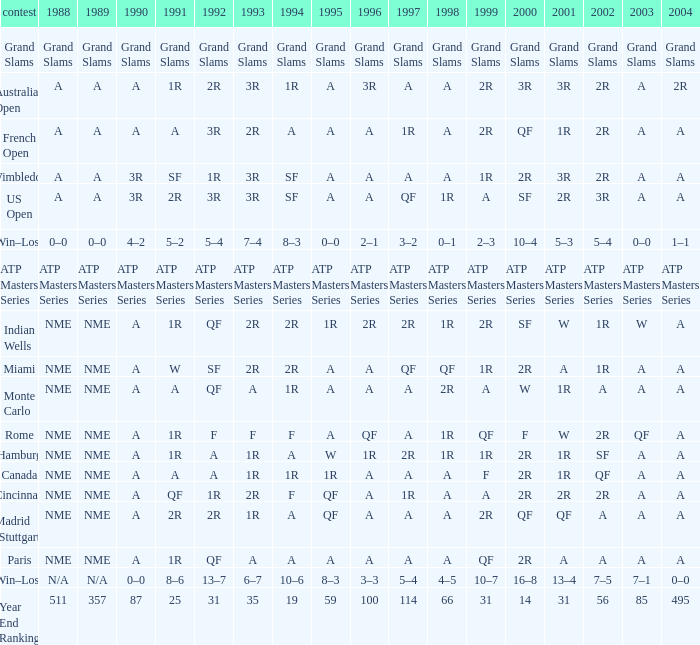What shows for 1988 when 1994 shows 10–6? N/A. 